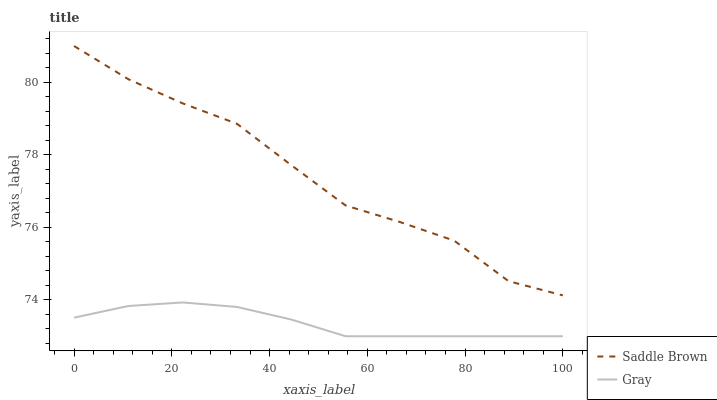Does Gray have the minimum area under the curve?
Answer yes or no. Yes. Does Saddle Brown have the maximum area under the curve?
Answer yes or no. Yes. Does Saddle Brown have the minimum area under the curve?
Answer yes or no. No. Is Gray the smoothest?
Answer yes or no. Yes. Is Saddle Brown the roughest?
Answer yes or no. Yes. Is Saddle Brown the smoothest?
Answer yes or no. No. Does Gray have the lowest value?
Answer yes or no. Yes. Does Saddle Brown have the lowest value?
Answer yes or no. No. Does Saddle Brown have the highest value?
Answer yes or no. Yes. Is Gray less than Saddle Brown?
Answer yes or no. Yes. Is Saddle Brown greater than Gray?
Answer yes or no. Yes. Does Gray intersect Saddle Brown?
Answer yes or no. No. 